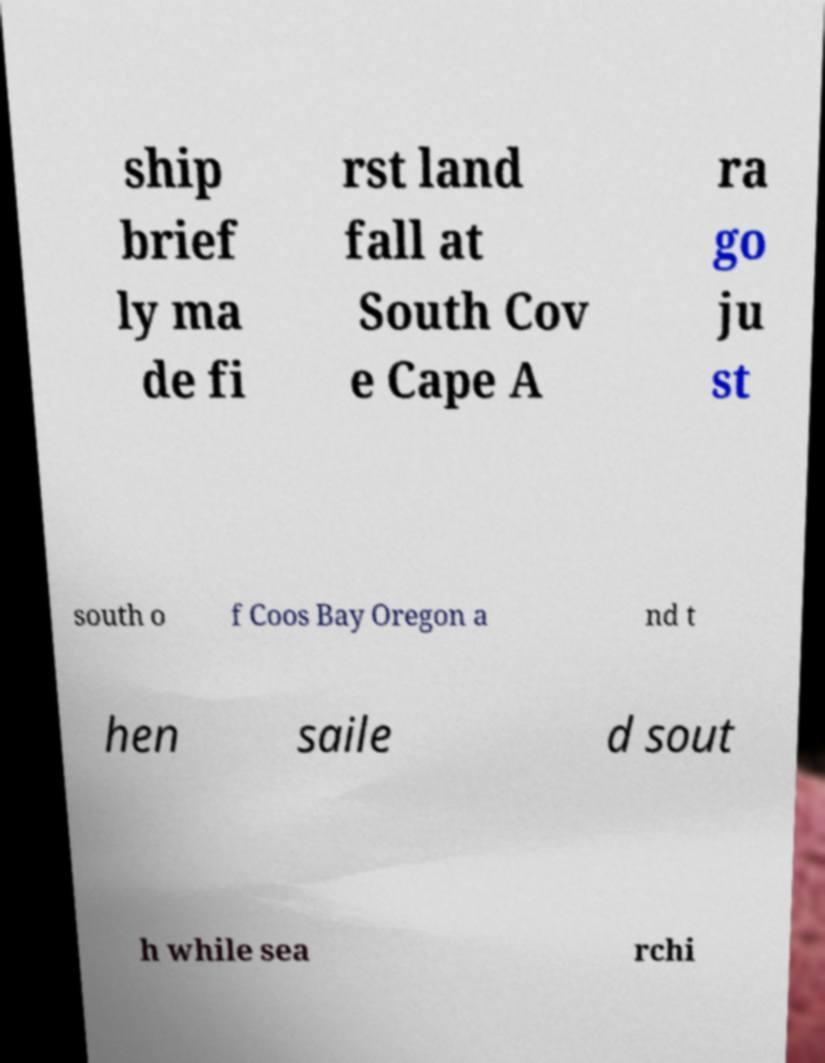Can you read and provide the text displayed in the image?This photo seems to have some interesting text. Can you extract and type it out for me? ship brief ly ma de fi rst land fall at South Cov e Cape A ra go ju st south o f Coos Bay Oregon a nd t hen saile d sout h while sea rchi 